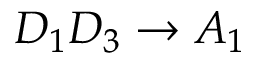<formula> <loc_0><loc_0><loc_500><loc_500>D _ { 1 } D _ { 3 } \rightarrow A _ { 1 }</formula> 